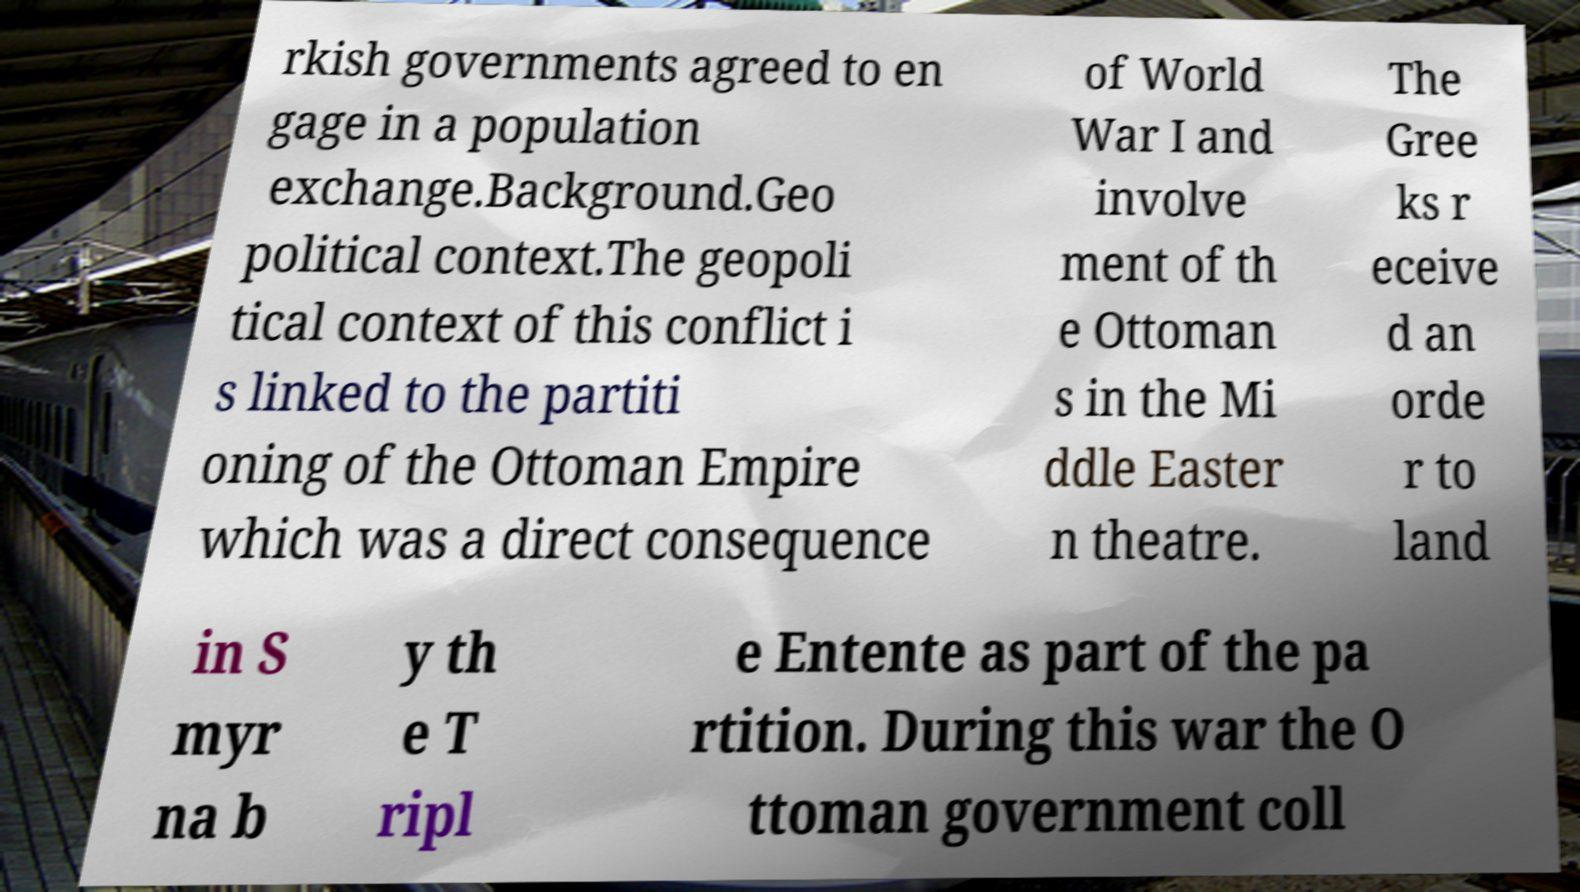For documentation purposes, I need the text within this image transcribed. Could you provide that? rkish governments agreed to en gage in a population exchange.Background.Geo political context.The geopoli tical context of this conflict i s linked to the partiti oning of the Ottoman Empire which was a direct consequence of World War I and involve ment of th e Ottoman s in the Mi ddle Easter n theatre. The Gree ks r eceive d an orde r to land in S myr na b y th e T ripl e Entente as part of the pa rtition. During this war the O ttoman government coll 